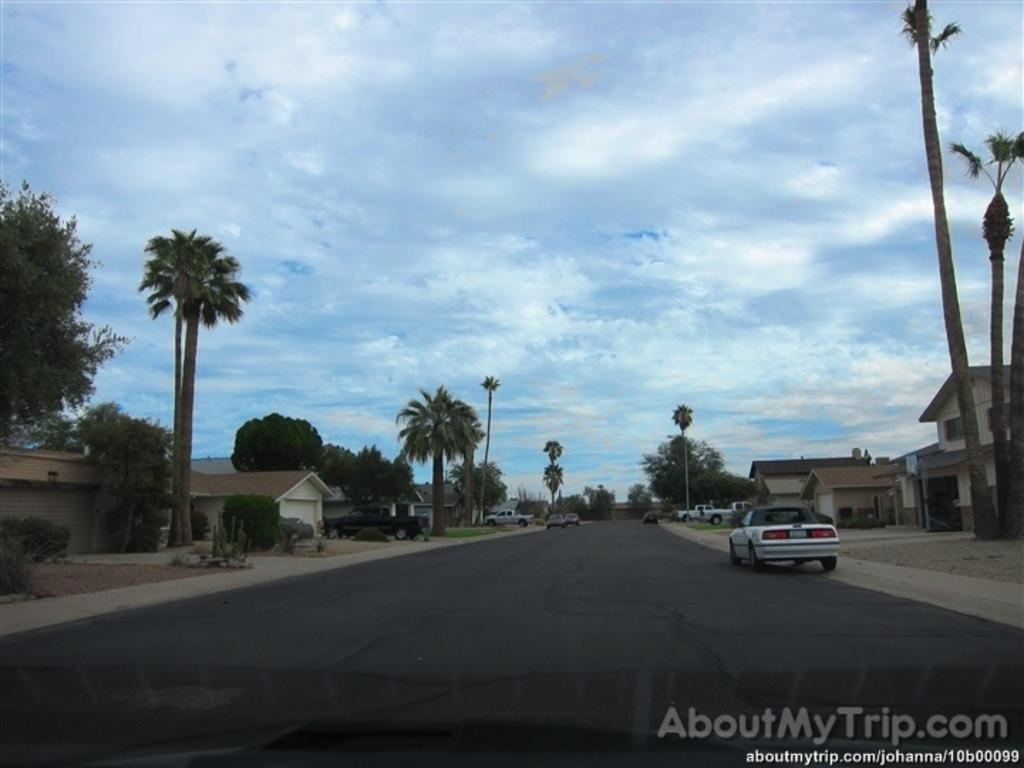What can be seen on the road in the image? There are vehicles on the road in the image. What type of structures are visible in the image? There are houses visible in the image. What natural elements can be seen in the image? There are trees and clouds present in the image. Can you describe the watermark at the bottom of the image? There is a watermark at the bottom of the image. What type of zipper can be seen on the trees in the image? There are no zippers present on the trees in the image. What color is the gold used to paint the houses in the image? There is no gold used to paint the houses in the image; they are not painted gold. 